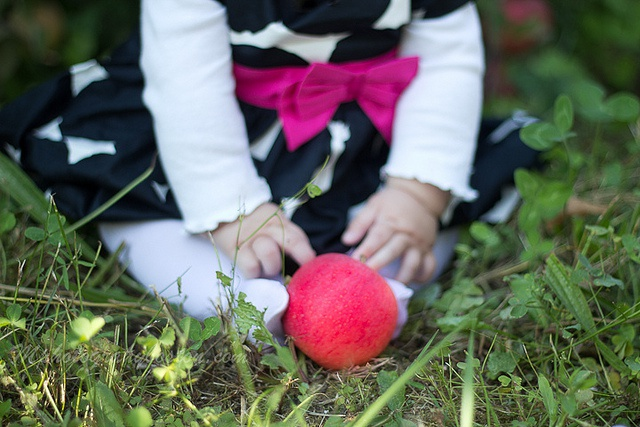Describe the objects in this image and their specific colors. I can see people in black, lavender, darkgray, and purple tones, tie in black and purple tones, and apple in black, brown, and salmon tones in this image. 